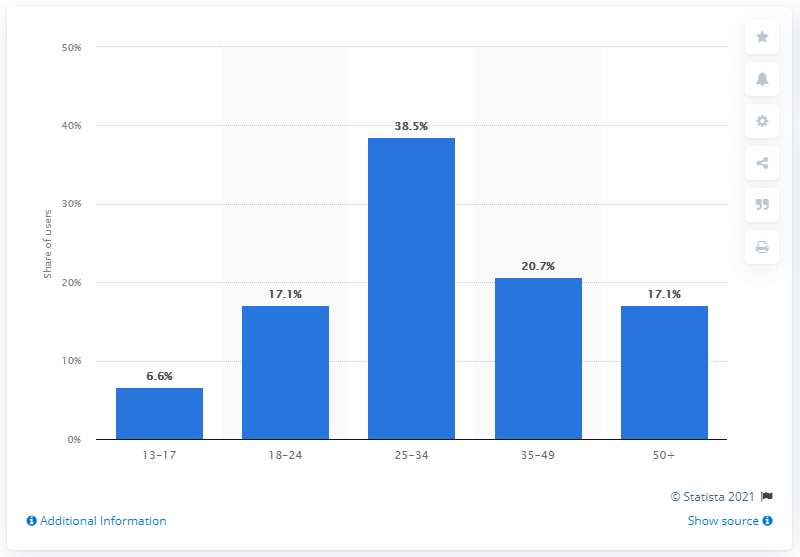Highlight a few significant elements in this photo. According to data from April 2021, 17.1% of users aged 50 and over were active on Twitter. As of April 2021, 38.5% of users aged between 25 and 34 were using Twitter. 